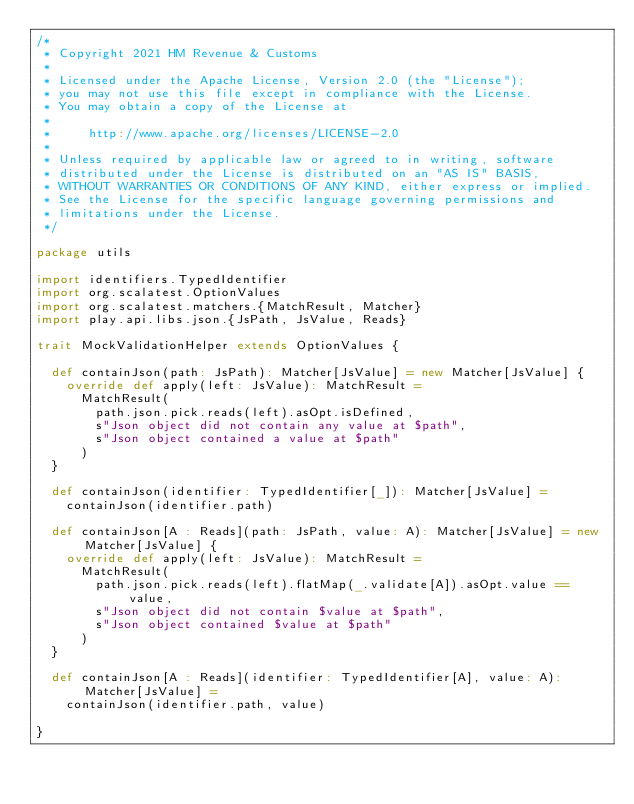Convert code to text. <code><loc_0><loc_0><loc_500><loc_500><_Scala_>/*
 * Copyright 2021 HM Revenue & Customs
 *
 * Licensed under the Apache License, Version 2.0 (the "License");
 * you may not use this file except in compliance with the License.
 * You may obtain a copy of the License at
 *
 *     http://www.apache.org/licenses/LICENSE-2.0
 *
 * Unless required by applicable law or agreed to in writing, software
 * distributed under the License is distributed on an "AS IS" BASIS,
 * WITHOUT WARRANTIES OR CONDITIONS OF ANY KIND, either express or implied.
 * See the License for the specific language governing permissions and
 * limitations under the License.
 */

package utils

import identifiers.TypedIdentifier
import org.scalatest.OptionValues
import org.scalatest.matchers.{MatchResult, Matcher}
import play.api.libs.json.{JsPath, JsValue, Reads}

trait MockValidationHelper extends OptionValues {

  def containJson(path: JsPath): Matcher[JsValue] = new Matcher[JsValue] {
    override def apply(left: JsValue): MatchResult =
      MatchResult(
        path.json.pick.reads(left).asOpt.isDefined,
        s"Json object did not contain any value at $path",
        s"Json object contained a value at $path"
      )
  }

  def containJson(identifier: TypedIdentifier[_]): Matcher[JsValue] =
    containJson(identifier.path)

  def containJson[A : Reads](path: JsPath, value: A): Matcher[JsValue] = new Matcher[JsValue] {
    override def apply(left: JsValue): MatchResult =
      MatchResult(
        path.json.pick.reads(left).flatMap(_.validate[A]).asOpt.value == value,
        s"Json object did not contain $value at $path",
        s"Json object contained $value at $path"
      )
  }

  def containJson[A : Reads](identifier: TypedIdentifier[A], value: A): Matcher[JsValue] =
    containJson(identifier.path, value)

}
</code> 